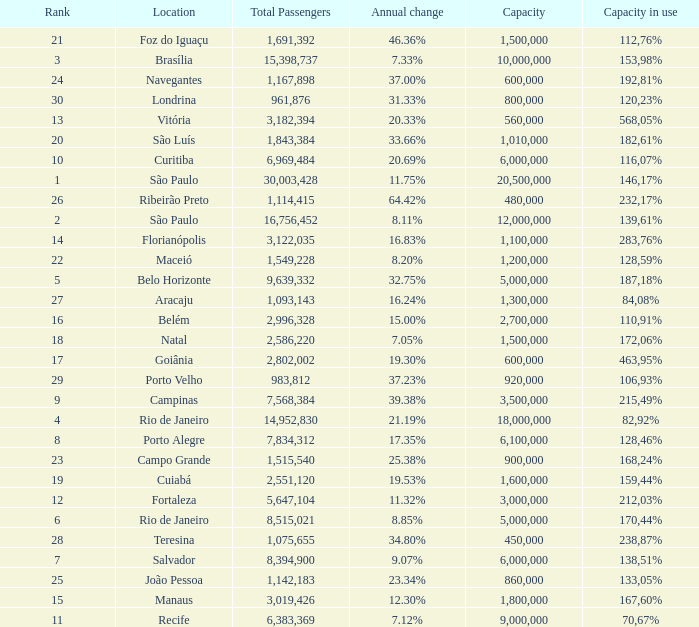Which location has a capacity that has a rank of 23? 168,24%. 